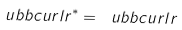<formula> <loc_0><loc_0><loc_500><loc_500>\ u b b c u r l r ^ { * } = \ u b b c u r l r</formula> 